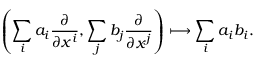Convert formula to latex. <formula><loc_0><loc_0><loc_500><loc_500>\left ( \sum _ { i } a _ { i } { \frac { \partial } { \partial x ^ { i } } } , \sum _ { j } b _ { j } { \frac { \partial } { \partial x ^ { j } } } \right ) \longmapsto \sum _ { i } a _ { i } b _ { i } .</formula> 